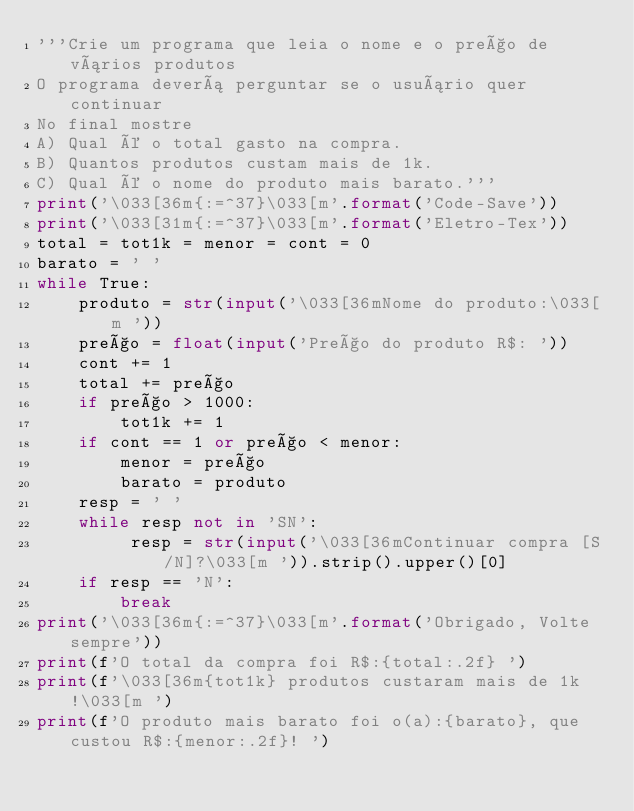Convert code to text. <code><loc_0><loc_0><loc_500><loc_500><_Python_>'''Crie um programa que leia o nome e o preço de vários produtos
O programa deverá perguntar se o usuário quer continuar 
No final mostre
A) Qual é o total gasto na compra.
B) Quantos produtos custam mais de 1k.
C) Qual é o nome do produto mais barato.'''
print('\033[36m{:=^37}\033[m'.format('Code-Save'))
print('\033[31m{:=^37}\033[m'.format('Eletro-Tex'))
total = tot1k = menor = cont = 0
barato = ' '
while True:
    produto = str(input('\033[36mNome do produto:\033[m '))
    preço = float(input('Preço do produto R$: '))
    cont += 1
    total += preço
    if preço > 1000:
        tot1k += 1
    if cont == 1 or preço < menor:
        menor = preço
        barato = produto
    resp = ' '
    while resp not in 'SN':
         resp = str(input('\033[36mContinuar compra [S/N]?\033[m ')).strip().upper()[0]
    if resp == 'N':
        break
print('\033[36m{:=^37}\033[m'.format('Obrigado, Volte sempre')) 
print(f'O total da compra foi R$:{total:.2f} ')
print(f'\033[36m{tot1k} produtos custaram mais de 1k!\033[m ')
print(f'O produto mais barato foi o(a):{barato}, que custou R$:{menor:.2f}! ')

</code> 